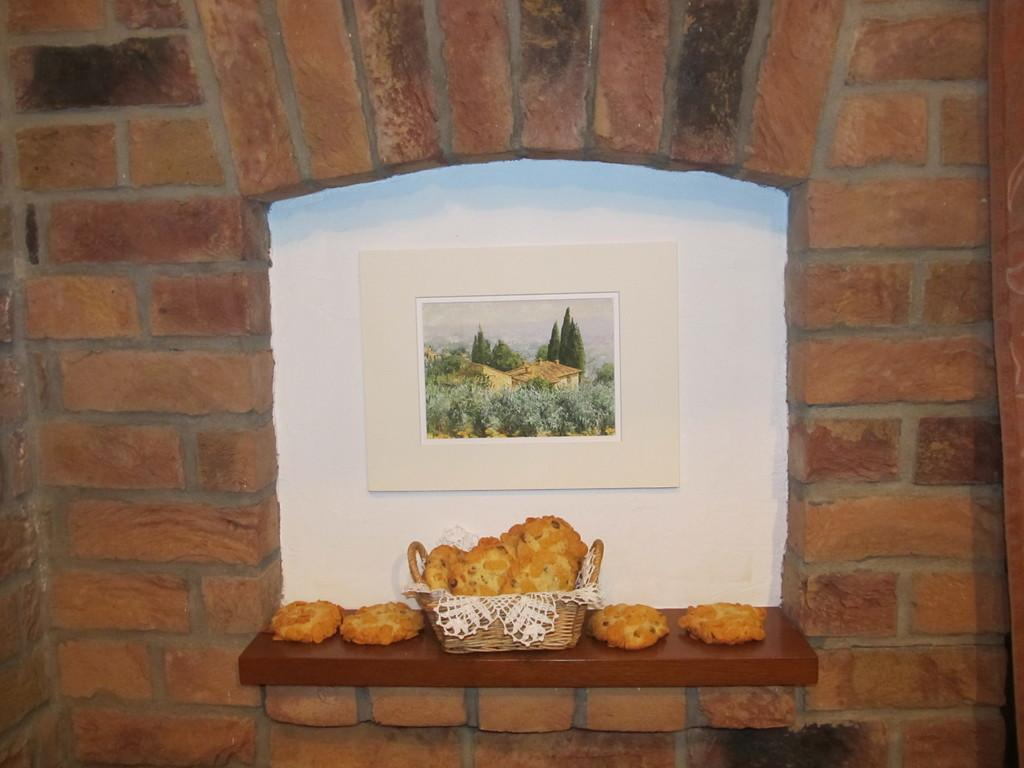Where was the image taken? The image was taken indoors. What can be seen on the wall in the image? There is a wall with a picture frame in the image. What is present on the shelf in the image? There is a shelf and a basket on it in the image. What is inside the basket on the shelf? The basket contains a few cookies. What type of potato is being taught how to play a toy in the image? There is no potato or toy present in the image. 